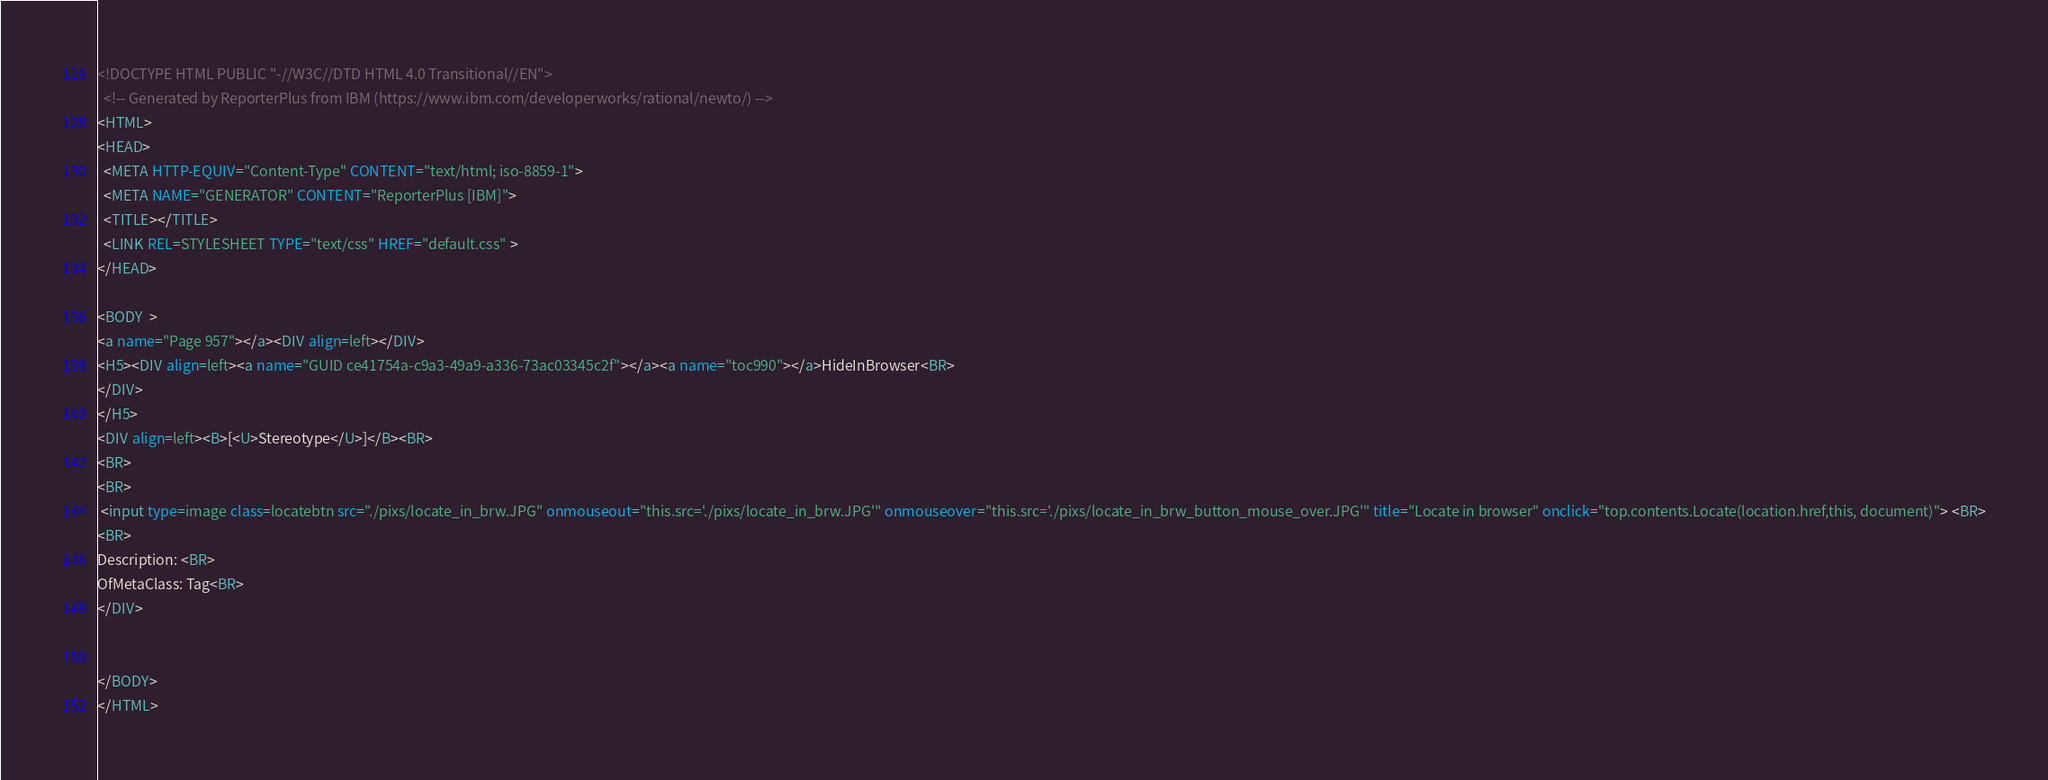<code> <loc_0><loc_0><loc_500><loc_500><_HTML_><!DOCTYPE HTML PUBLIC "-//W3C//DTD HTML 4.0 Transitional//EN">
  <!-- Generated by ReporterPlus from IBM (https://www.ibm.com/developerworks/rational/newto/) -->
<HTML>
<HEAD>
  <META HTTP-EQUIV="Content-Type" CONTENT="text/html; iso-8859-1">
  <META NAME="GENERATOR" CONTENT="ReporterPlus [IBM]">
  <TITLE></TITLE>
  <LINK REL=STYLESHEET TYPE="text/css" HREF="default.css" >
</HEAD>

<BODY  >
<a name="Page 957"></a><DIV align=left></DIV>
<H5><DIV align=left><a name="GUID ce41754a-c9a3-49a9-a336-73ac03345c2f"></a><a name="toc990"></a>HideInBrowser<BR>
</DIV>
</H5>
<DIV align=left><B>[<U>Stereotype</U>]</B><BR>
<BR>
<BR>
 <input type=image class=locatebtn src="./pixs/locate_in_brw.JPG" onmouseout="this.src='./pixs/locate_in_brw.JPG'" onmouseover="this.src='./pixs/locate_in_brw_button_mouse_over.JPG'" title="Locate in browser" onclick="top.contents.Locate(location.href,this, document)"> <BR>
<BR>
Description: <BR>
OfMetaClass: Tag<BR>
</DIV>


</BODY>
</HTML>
</code> 